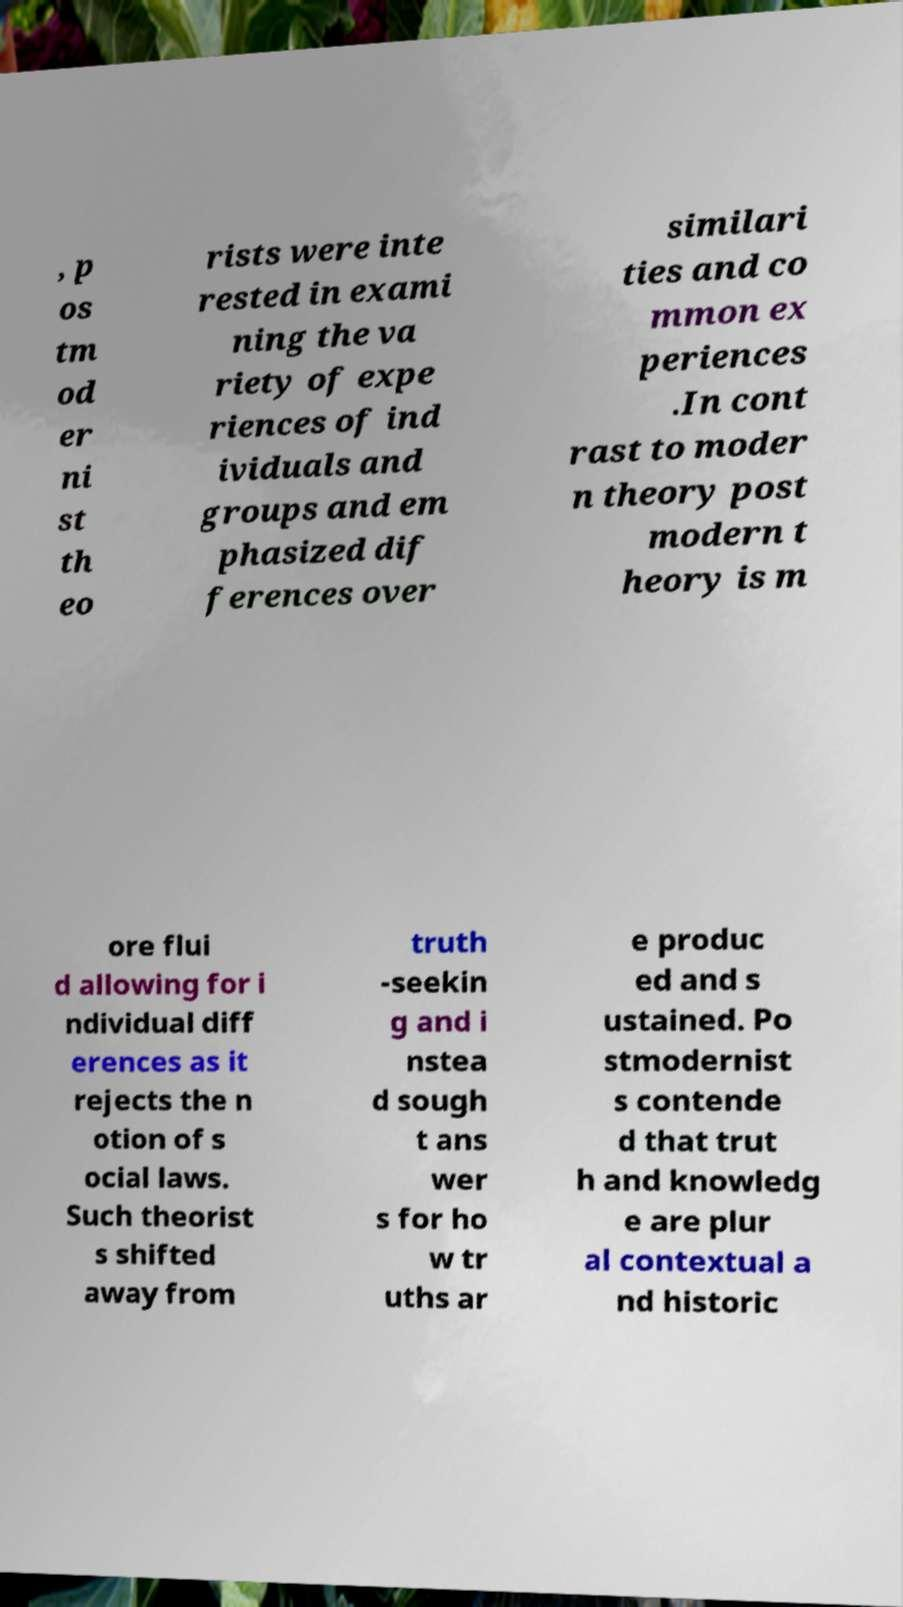What messages or text are displayed in this image? I need them in a readable, typed format. , p os tm od er ni st th eo rists were inte rested in exami ning the va riety of expe riences of ind ividuals and groups and em phasized dif ferences over similari ties and co mmon ex periences .In cont rast to moder n theory post modern t heory is m ore flui d allowing for i ndividual diff erences as it rejects the n otion of s ocial laws. Such theorist s shifted away from truth -seekin g and i nstea d sough t ans wer s for ho w tr uths ar e produc ed and s ustained. Po stmodernist s contende d that trut h and knowledg e are plur al contextual a nd historic 